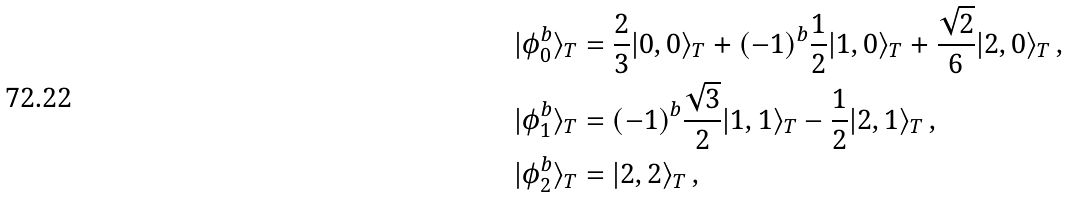<formula> <loc_0><loc_0><loc_500><loc_500>| \phi _ { 0 } ^ { b } \rangle _ { T } & = \frac { 2 } { 3 } | 0 , 0 \rangle _ { T } + ( - 1 ) ^ { b } \frac { 1 } { 2 } | 1 , 0 \rangle _ { T } + \frac { \sqrt { 2 } } { 6 } | 2 , 0 \rangle _ { T } \, , \\ | \phi _ { 1 } ^ { b } \rangle _ { T } & = ( - 1 ) ^ { b } \frac { \sqrt { 3 } } { 2 } | 1 , 1 \rangle _ { T } - \frac { 1 } { 2 } | 2 , 1 \rangle _ { T } \, , \\ | \phi _ { 2 } ^ { b } \rangle _ { T } & = | 2 , 2 \rangle _ { T } \, ,</formula> 